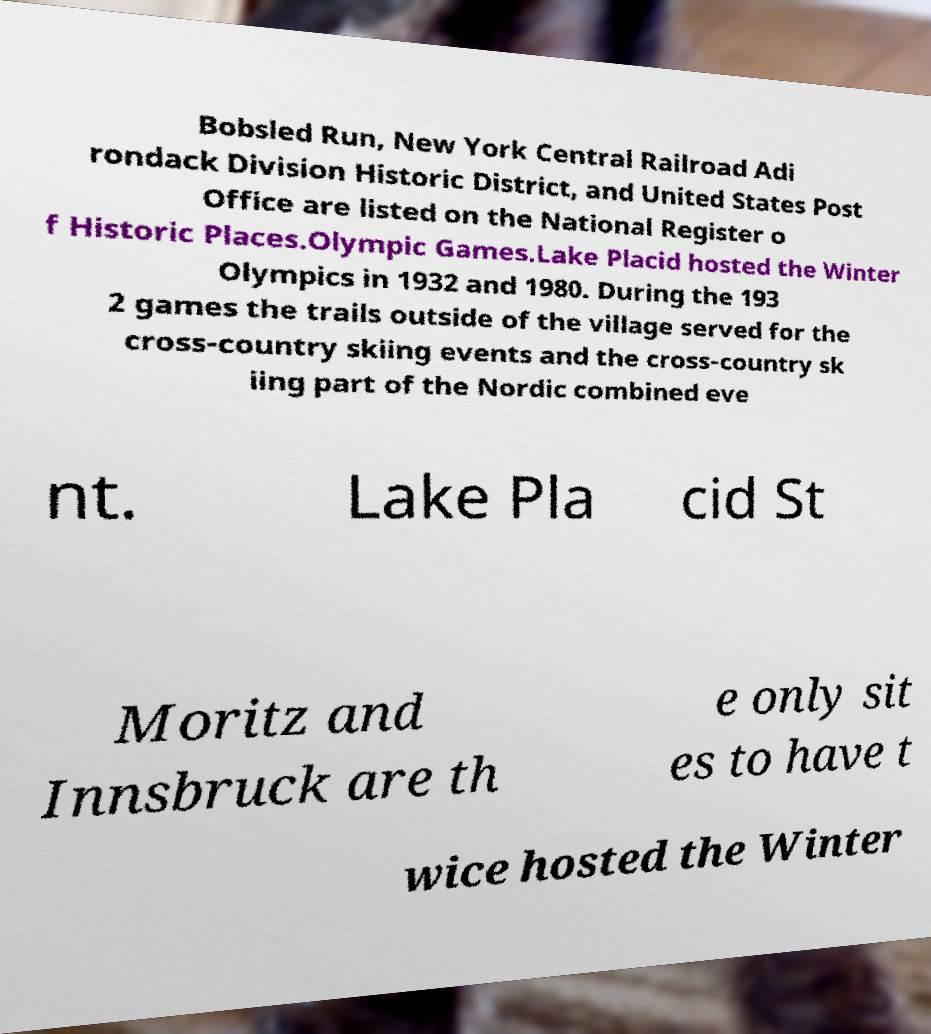Please identify and transcribe the text found in this image. Bobsled Run, New York Central Railroad Adi rondack Division Historic District, and United States Post Office are listed on the National Register o f Historic Places.Olympic Games.Lake Placid hosted the Winter Olympics in 1932 and 1980. During the 193 2 games the trails outside of the village served for the cross-country skiing events and the cross-country sk iing part of the Nordic combined eve nt. Lake Pla cid St Moritz and Innsbruck are th e only sit es to have t wice hosted the Winter 